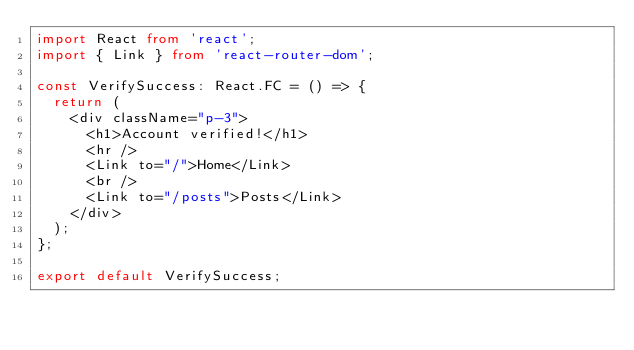<code> <loc_0><loc_0><loc_500><loc_500><_TypeScript_>import React from 'react';
import { Link } from 'react-router-dom';

const VerifySuccess: React.FC = () => {
	return (
		<div className="p-3">
			<h1>Account verified!</h1>
			<hr />
			<Link to="/">Home</Link>
			<br />
			<Link to="/posts">Posts</Link>
		</div>
	);
};

export default VerifySuccess;
</code> 